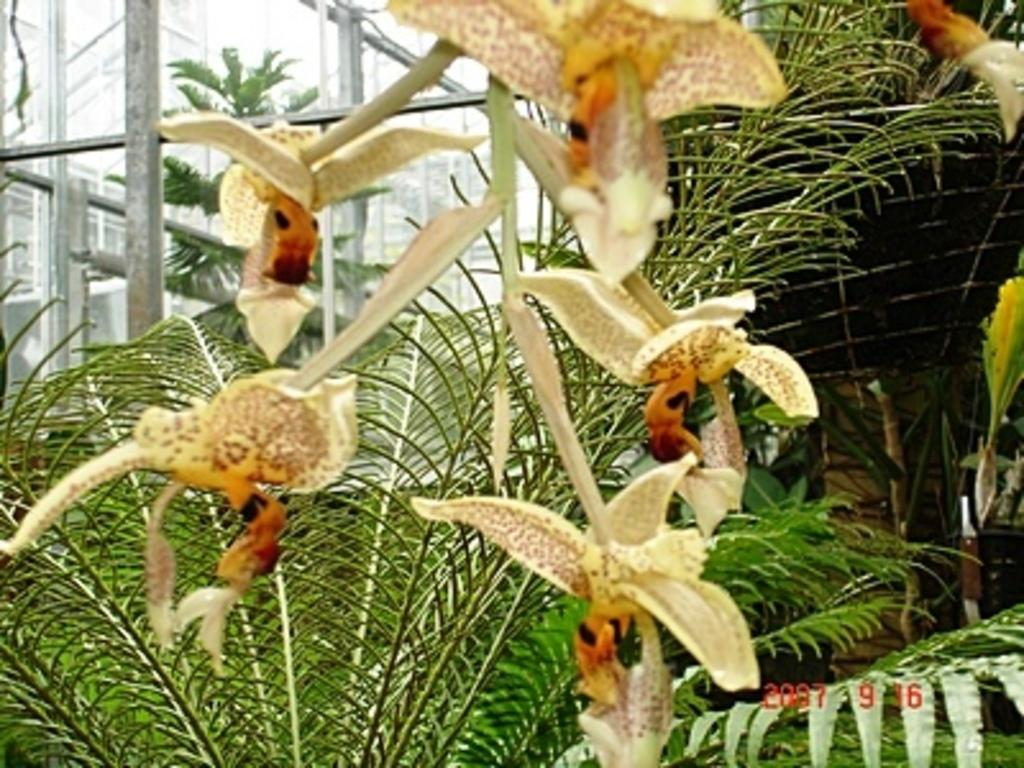What type of plant is visible in the image? There is a flower in the image. What other types of plants can be seen in the image? There are plants visible in the image. What is located in the background of the image? There is a tree and poles in the background of the image. Can you see the grass growing in the image? There is no grass visible in the image. Is there any smoke coming from the flower in the image? There is no smoke present in the image. 